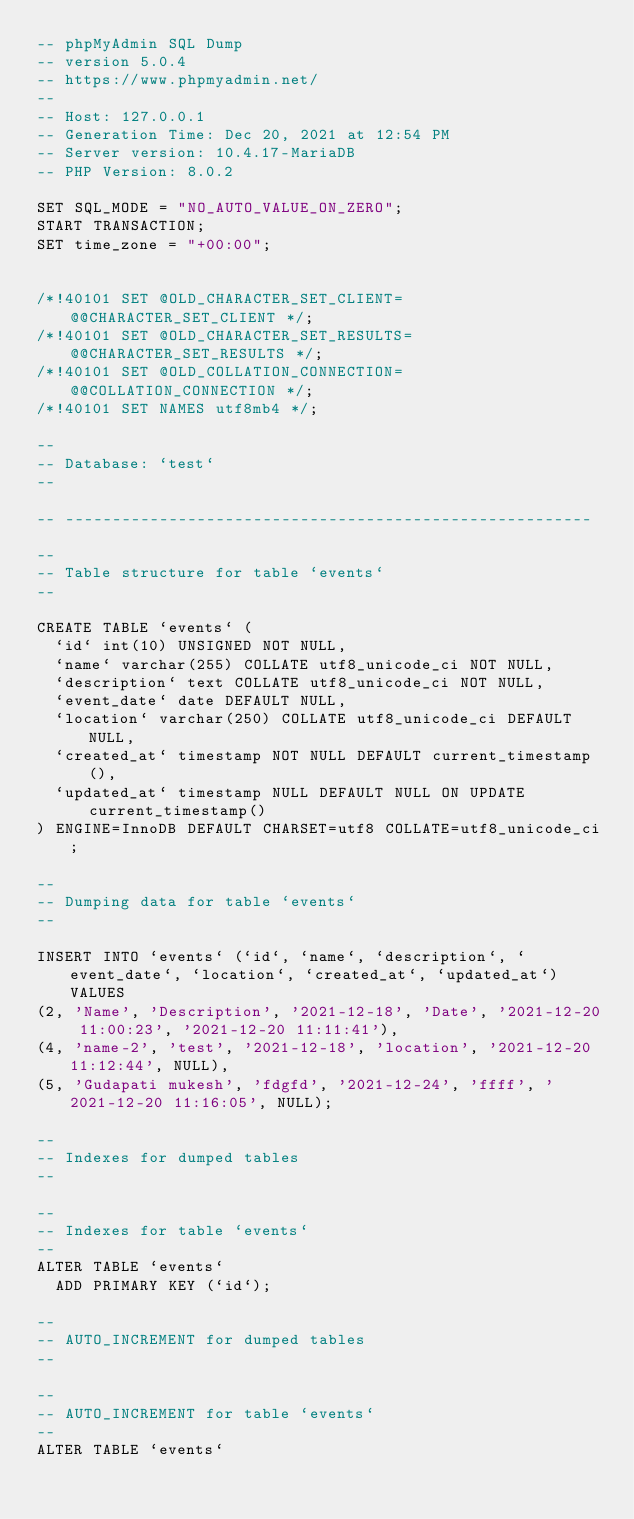<code> <loc_0><loc_0><loc_500><loc_500><_SQL_>-- phpMyAdmin SQL Dump
-- version 5.0.4
-- https://www.phpmyadmin.net/
--
-- Host: 127.0.0.1
-- Generation Time: Dec 20, 2021 at 12:54 PM
-- Server version: 10.4.17-MariaDB
-- PHP Version: 8.0.2

SET SQL_MODE = "NO_AUTO_VALUE_ON_ZERO";
START TRANSACTION;
SET time_zone = "+00:00";


/*!40101 SET @OLD_CHARACTER_SET_CLIENT=@@CHARACTER_SET_CLIENT */;
/*!40101 SET @OLD_CHARACTER_SET_RESULTS=@@CHARACTER_SET_RESULTS */;
/*!40101 SET @OLD_COLLATION_CONNECTION=@@COLLATION_CONNECTION */;
/*!40101 SET NAMES utf8mb4 */;

--
-- Database: `test`
--

-- --------------------------------------------------------

--
-- Table structure for table `events`
--

CREATE TABLE `events` (
  `id` int(10) UNSIGNED NOT NULL,
  `name` varchar(255) COLLATE utf8_unicode_ci NOT NULL,
  `description` text COLLATE utf8_unicode_ci NOT NULL,
  `event_date` date DEFAULT NULL,
  `location` varchar(250) COLLATE utf8_unicode_ci DEFAULT NULL,
  `created_at` timestamp NOT NULL DEFAULT current_timestamp(),
  `updated_at` timestamp NULL DEFAULT NULL ON UPDATE current_timestamp()
) ENGINE=InnoDB DEFAULT CHARSET=utf8 COLLATE=utf8_unicode_ci;

--
-- Dumping data for table `events`
--

INSERT INTO `events` (`id`, `name`, `description`, `event_date`, `location`, `created_at`, `updated_at`) VALUES
(2, 'Name', 'Description', '2021-12-18', 'Date', '2021-12-20 11:00:23', '2021-12-20 11:11:41'),
(4, 'name-2', 'test', '2021-12-18', 'location', '2021-12-20 11:12:44', NULL),
(5, 'Gudapati mukesh', 'fdgfd', '2021-12-24', 'ffff', '2021-12-20 11:16:05', NULL);

--
-- Indexes for dumped tables
--

--
-- Indexes for table `events`
--
ALTER TABLE `events`
  ADD PRIMARY KEY (`id`);

--
-- AUTO_INCREMENT for dumped tables
--

--
-- AUTO_INCREMENT for table `events`
--
ALTER TABLE `events`</code> 